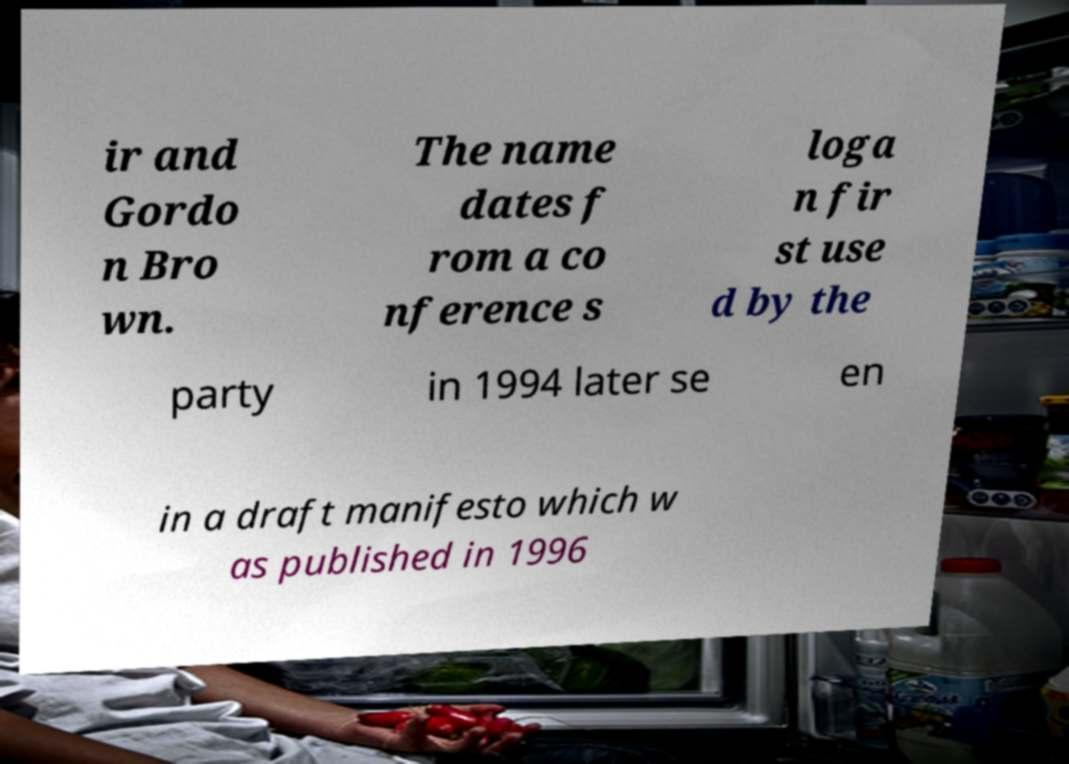Can you accurately transcribe the text from the provided image for me? ir and Gordo n Bro wn. The name dates f rom a co nference s loga n fir st use d by the party in 1994 later se en in a draft manifesto which w as published in 1996 